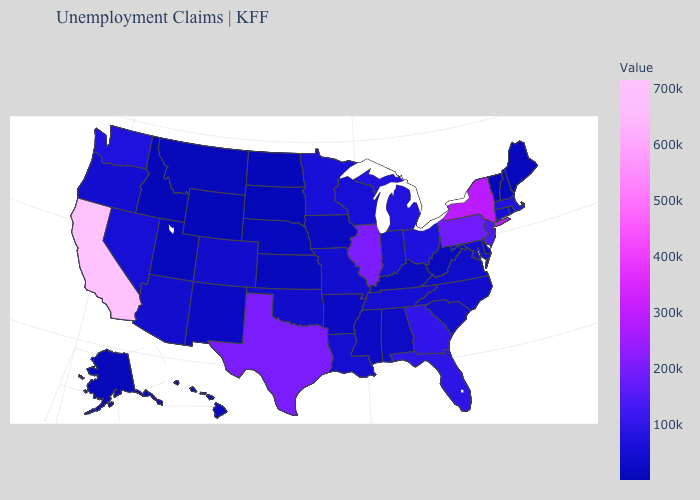Among the states that border Montana , which have the lowest value?
Answer briefly. South Dakota. Among the states that border Illinois , does Iowa have the highest value?
Concise answer only. No. Does Louisiana have the lowest value in the South?
Be succinct. No. Does California have the highest value in the USA?
Keep it brief. Yes. 